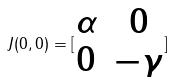Convert formula to latex. <formula><loc_0><loc_0><loc_500><loc_500>J ( 0 , 0 ) = [ \begin{matrix} \alpha & 0 \\ 0 & - \gamma \end{matrix} ]</formula> 